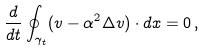Convert formula to latex. <formula><loc_0><loc_0><loc_500><loc_500>\frac { d } { d t } \oint _ { \gamma _ { t } } ( v - \alpha ^ { 2 } \Delta v ) \cdot d x = 0 \, ,</formula> 